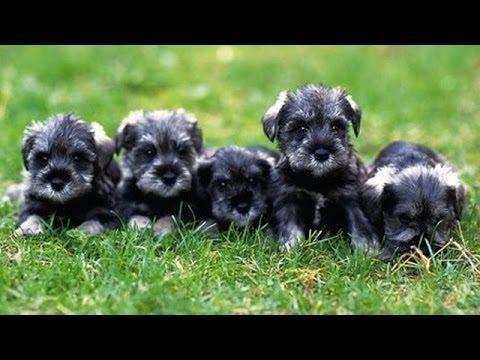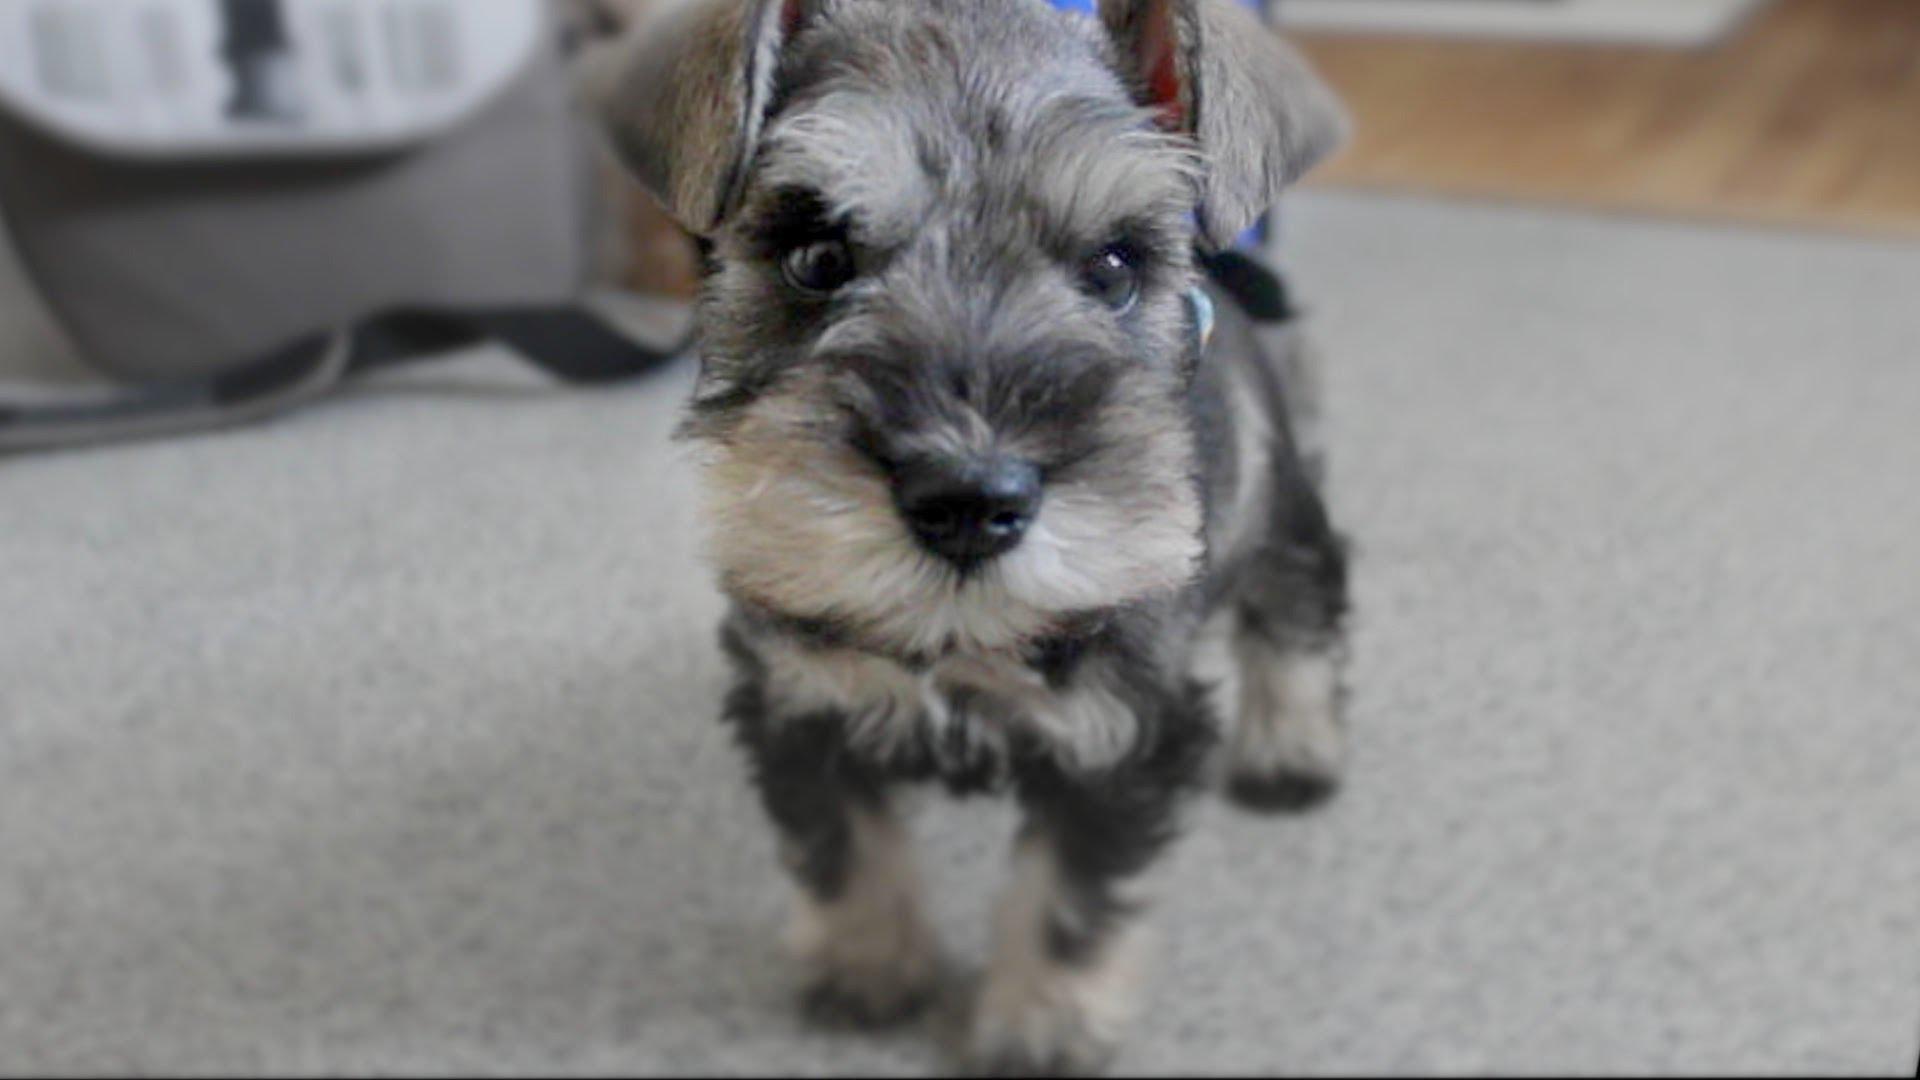The first image is the image on the left, the second image is the image on the right. For the images displayed, is the sentence "There are exactly five puppies in one of the images." factually correct? Answer yes or no. Yes. 